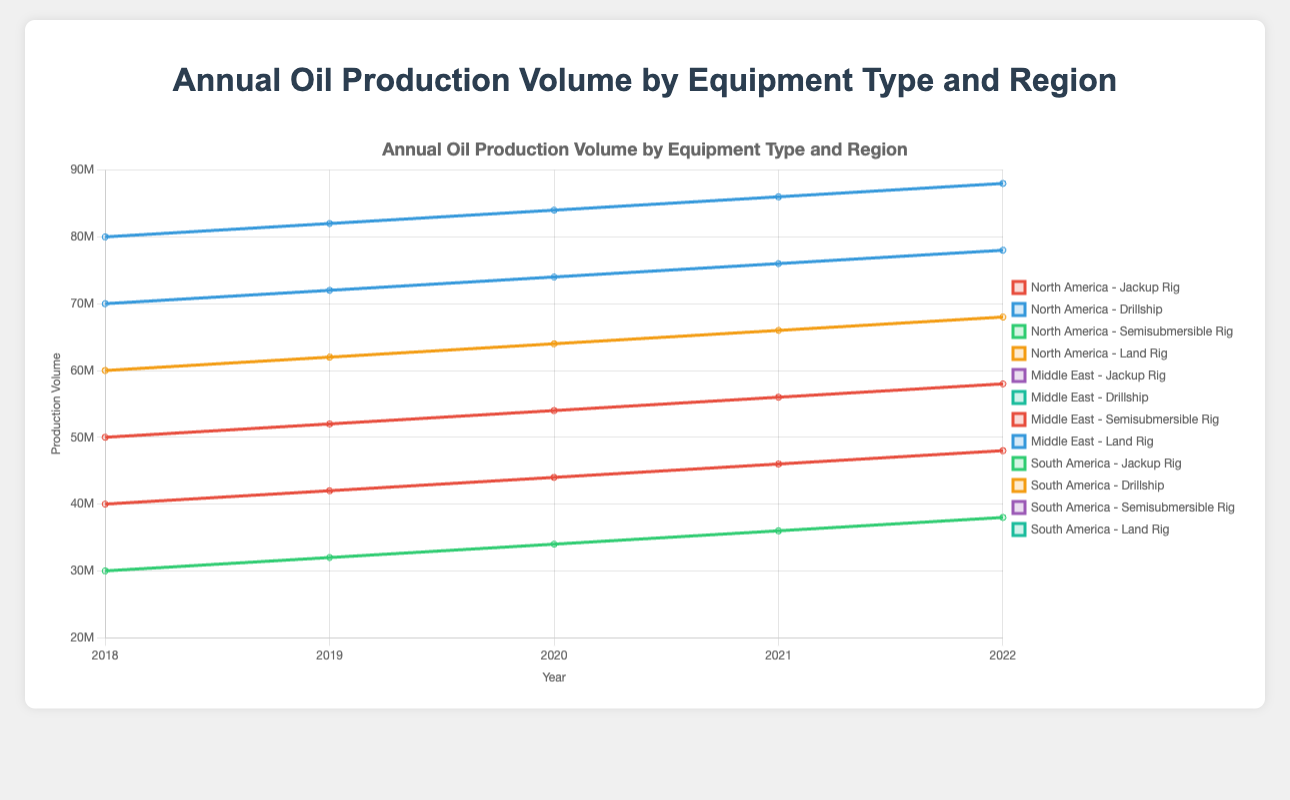Which region and equipment type had the highest production volume in 2022? Look at the legend to identify the respective regions and equipment types. Then, check the lines ending at the year 2022 on the x-axis and find the highest production volume point on the y-axis. The composition of this highest point will reveal the region and equipment type.
Answer: Middle East - Land Rig By how much did the oil production volume increase for North America's Jackup Rig from 2018 to 2022? Find the positions of North America - Jackup Rig at years 2018 and 2022 on the x-axis. Then, look at the corresponding production volume values on the y-axis. Subtract the 2018 value from the 2022 value to get the increase.
Answer: 8000000 Which equipment type saw the least variation in production volume in South America between 2018 and 2022? For South America, analyze each equipment type's production volumes from 2018 to 2022. Calculate the range (maximum value - minimum value) for each equipment type and identify the one with the smallest range.
Answer: Drillship In 2021 across all regions, which equipment type had the highest average production volume? Collect all production volumes of each equipment type for each region in 2021. Calculate the average for each type by dividing the total production volume by the number of data points (regions). Identify the highest average.
Answer: Land Rig Was there a continual increase in production volume for Middle East's Semisubmersible Rig from 2018 to 2022? Trace the line representing Middle East - Semisubmersible Rig from 2018 to 2022. Check if each year the value is higher than the previous year.
Answer: Yes What is the percentage increase in production volume for South America's Drillship from 2020 to 2022? Find the production volumes of South America - Drillship at 2020 and 2022. Calculate the difference and then the percentage increase using the formula: ((volume in 2022 - volume in 2020) / volume in 2020) * 100%.
Answer: 6.25% Compare the production volumes of Middle East's Land Rig and North America's Drillship in 2018. Which region had higher production? Locate the production volumes for Middle East - Land Rig and North America - Drillship at 2018 on the y-axis and compare them. Identify which one is higher.
Answer: Middle East - Land Rig Across all years, what insight can be derived about North America's choice of equipment based on production volumes? Evaluate the patterns of production volumes for North America - Jackup Rig and Drillship from 2018 to 2022 to see if one equipment type is consistently used more.
Answer: Drillship consistently has higher production By how much did the production volume for Middle East's Land Rig exceed North America's Jackup Rig in 2020? Find the production volumes for Middle East - Land Rig and North America - Jackup Rig at 2020. Subtract the latter from the former to get the difference.
Answer: 30000000 